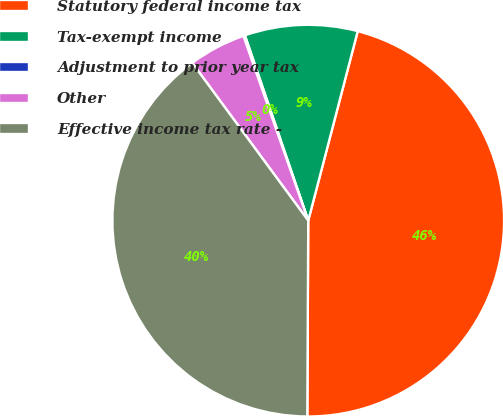<chart> <loc_0><loc_0><loc_500><loc_500><pie_chart><fcel>Statutory federal income tax<fcel>Tax-exempt income<fcel>Adjustment to prior year tax<fcel>Other<fcel>Effective income tax rate -<nl><fcel>46.01%<fcel>9.31%<fcel>0.13%<fcel>4.72%<fcel>39.83%<nl></chart> 